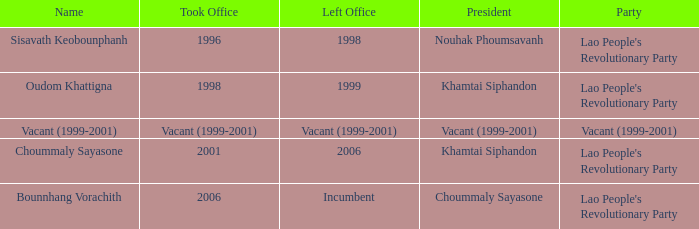What is Left Office, when Took Office is 2006? Incumbent. 